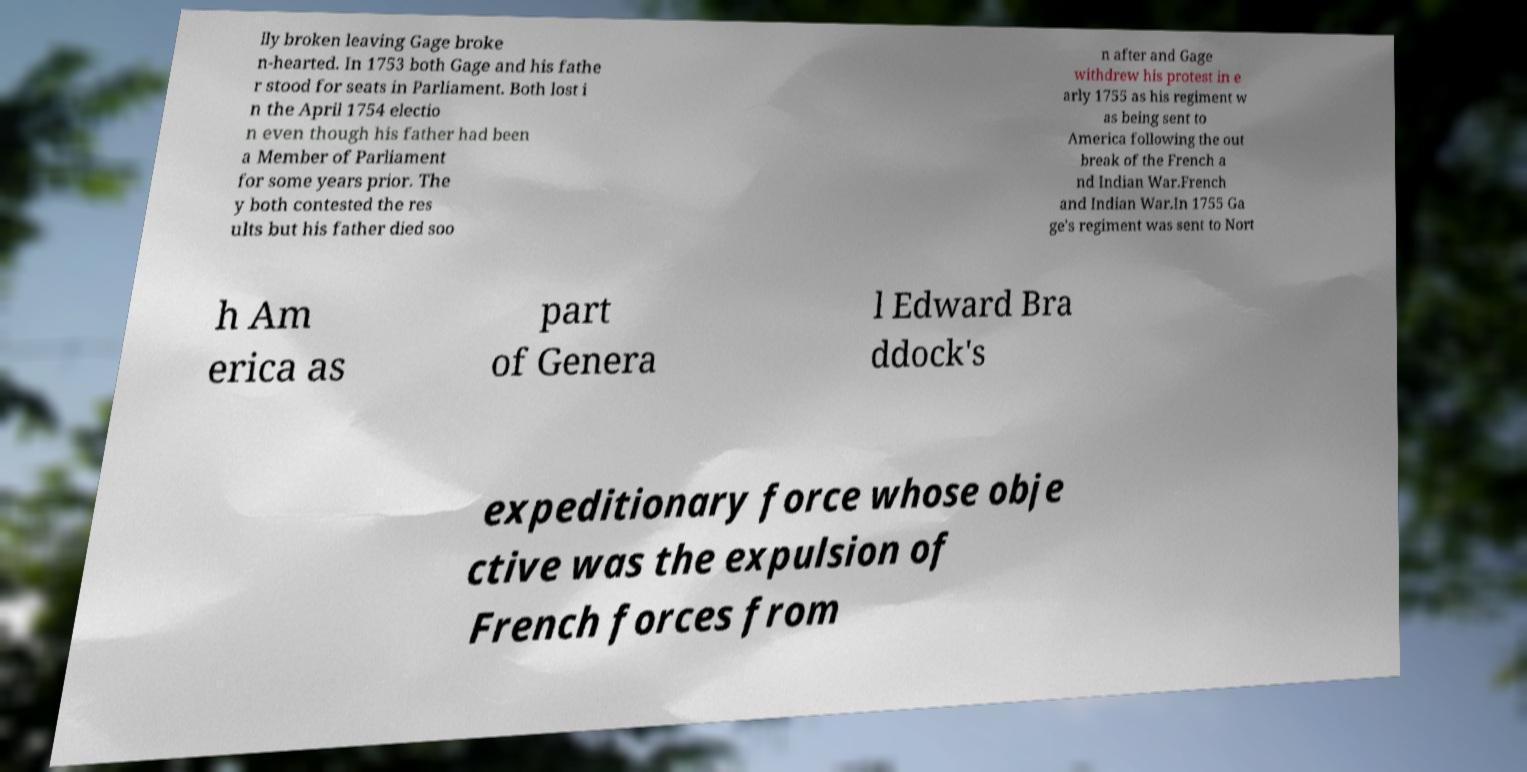For documentation purposes, I need the text within this image transcribed. Could you provide that? lly broken leaving Gage broke n-hearted. In 1753 both Gage and his fathe r stood for seats in Parliament. Both lost i n the April 1754 electio n even though his father had been a Member of Parliament for some years prior. The y both contested the res ults but his father died soo n after and Gage withdrew his protest in e arly 1755 as his regiment w as being sent to America following the out break of the French a nd Indian War.French and Indian War.In 1755 Ga ge's regiment was sent to Nort h Am erica as part of Genera l Edward Bra ddock's expeditionary force whose obje ctive was the expulsion of French forces from 